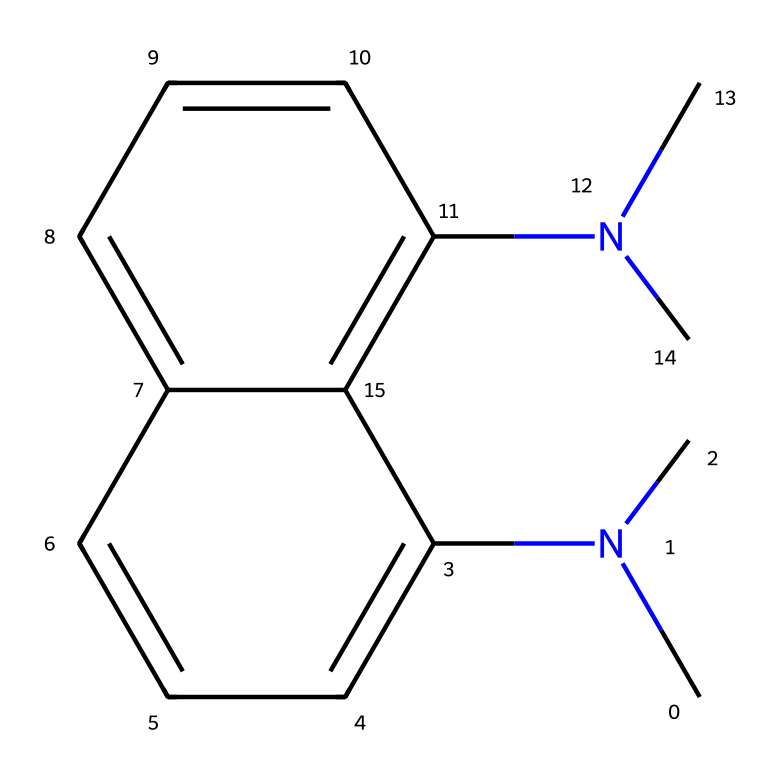What is the total number of nitrogen atoms in this chemical? By examining the SMILES, we identify two dimethylamino groups, each contributing one nitrogen atom. Therefore, counting these gives us a total of two nitrogen atoms in the entire molecule.
Answer: 2 What type of bonding exists between the naphthalene rings? The structure includes aromatic naphthalene rings, which are characterized by conjugated pi systems. The bonds between the carbon atoms in these rings are primarily double bonds, indicating that they are involved in resonance stabilization typical of aromatic compounds.
Answer: aromatic bonds How many carbon atoms are present in the chemical? Analyzing the SMILES notation, we find there are ten carbon atoms from the naphthalene structure, plus four carbon atoms from the two dimethylamino groups. Adding these together provides a total of fourteen carbon atoms in this chemical.
Answer: 14 What molecular feature contributes to the strong basicity of this compound? The presence of the two dimethylamino groups, which are basic functional groups, contributes significantly to the strong basicity of the molecule. Each dimethylamino group can donate a lone pair of electrons, increasing the overall basic character of the chemical.
Answer: dimethylamino groups Is this chemical likely to act as a proton sponge? The presence of the two dimethylamino groups suggests that it can effectively sequester protons. This unique molecular architecture allows for stabilization of protons due to its electron-rich nature, hence confirming its behavior as a proton sponge.
Answer: yes What is the name of this compound? The compound is commonly known as "proton sponge," due to its ability to absorb protons and exhibit high basicity which is a characteristic of superbases.
Answer: proton sponge 